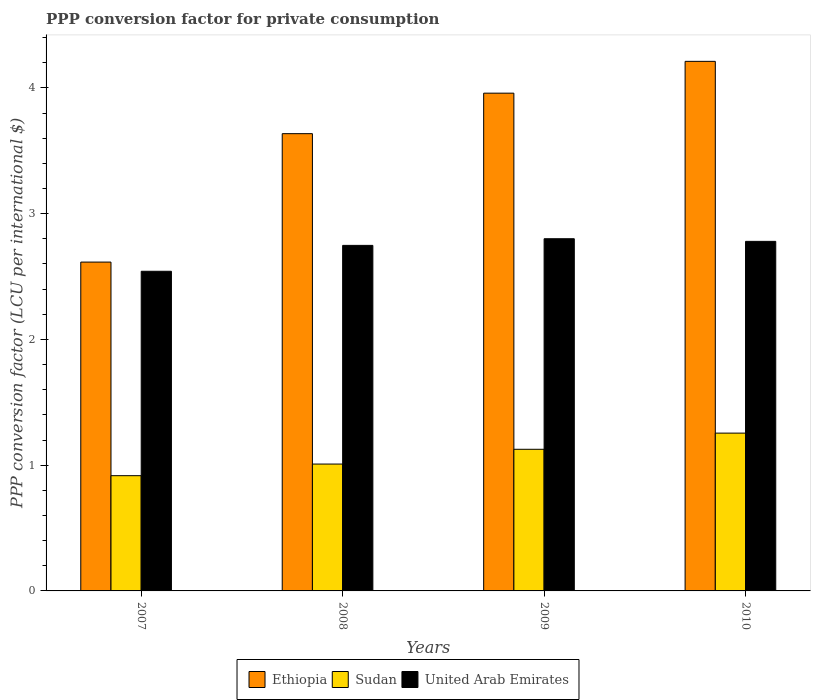How many different coloured bars are there?
Your response must be concise. 3. Are the number of bars on each tick of the X-axis equal?
Your response must be concise. Yes. What is the label of the 1st group of bars from the left?
Offer a very short reply. 2007. What is the PPP conversion factor for private consumption in Ethiopia in 2008?
Your answer should be very brief. 3.64. Across all years, what is the maximum PPP conversion factor for private consumption in United Arab Emirates?
Your response must be concise. 2.8. Across all years, what is the minimum PPP conversion factor for private consumption in United Arab Emirates?
Provide a succinct answer. 2.54. What is the total PPP conversion factor for private consumption in Sudan in the graph?
Ensure brevity in your answer.  4.31. What is the difference between the PPP conversion factor for private consumption in Sudan in 2007 and that in 2009?
Offer a terse response. -0.21. What is the difference between the PPP conversion factor for private consumption in Sudan in 2010 and the PPP conversion factor for private consumption in United Arab Emirates in 2009?
Your response must be concise. -1.55. What is the average PPP conversion factor for private consumption in United Arab Emirates per year?
Provide a short and direct response. 2.72. In the year 2007, what is the difference between the PPP conversion factor for private consumption in Ethiopia and PPP conversion factor for private consumption in United Arab Emirates?
Offer a terse response. 0.07. What is the ratio of the PPP conversion factor for private consumption in Ethiopia in 2008 to that in 2009?
Make the answer very short. 0.92. Is the PPP conversion factor for private consumption in Sudan in 2009 less than that in 2010?
Provide a short and direct response. Yes. What is the difference between the highest and the second highest PPP conversion factor for private consumption in Sudan?
Your answer should be compact. 0.13. What is the difference between the highest and the lowest PPP conversion factor for private consumption in Ethiopia?
Ensure brevity in your answer.  1.6. Is the sum of the PPP conversion factor for private consumption in Ethiopia in 2008 and 2010 greater than the maximum PPP conversion factor for private consumption in Sudan across all years?
Give a very brief answer. Yes. What does the 2nd bar from the left in 2008 represents?
Give a very brief answer. Sudan. What does the 3rd bar from the right in 2008 represents?
Ensure brevity in your answer.  Ethiopia. Is it the case that in every year, the sum of the PPP conversion factor for private consumption in United Arab Emirates and PPP conversion factor for private consumption in Sudan is greater than the PPP conversion factor for private consumption in Ethiopia?
Offer a terse response. No. How many years are there in the graph?
Ensure brevity in your answer.  4. What is the difference between two consecutive major ticks on the Y-axis?
Provide a short and direct response. 1. Does the graph contain grids?
Offer a very short reply. No. Where does the legend appear in the graph?
Provide a succinct answer. Bottom center. How are the legend labels stacked?
Your answer should be compact. Horizontal. What is the title of the graph?
Keep it short and to the point. PPP conversion factor for private consumption. What is the label or title of the X-axis?
Give a very brief answer. Years. What is the label or title of the Y-axis?
Give a very brief answer. PPP conversion factor (LCU per international $). What is the PPP conversion factor (LCU per international $) of Ethiopia in 2007?
Your response must be concise. 2.61. What is the PPP conversion factor (LCU per international $) in Sudan in 2007?
Offer a very short reply. 0.92. What is the PPP conversion factor (LCU per international $) in United Arab Emirates in 2007?
Make the answer very short. 2.54. What is the PPP conversion factor (LCU per international $) in Ethiopia in 2008?
Your response must be concise. 3.64. What is the PPP conversion factor (LCU per international $) of Sudan in 2008?
Ensure brevity in your answer.  1.01. What is the PPP conversion factor (LCU per international $) in United Arab Emirates in 2008?
Your response must be concise. 2.75. What is the PPP conversion factor (LCU per international $) in Ethiopia in 2009?
Your answer should be compact. 3.96. What is the PPP conversion factor (LCU per international $) of Sudan in 2009?
Give a very brief answer. 1.13. What is the PPP conversion factor (LCU per international $) of United Arab Emirates in 2009?
Offer a terse response. 2.8. What is the PPP conversion factor (LCU per international $) of Ethiopia in 2010?
Offer a terse response. 4.21. What is the PPP conversion factor (LCU per international $) of Sudan in 2010?
Give a very brief answer. 1.25. What is the PPP conversion factor (LCU per international $) of United Arab Emirates in 2010?
Give a very brief answer. 2.78. Across all years, what is the maximum PPP conversion factor (LCU per international $) of Ethiopia?
Provide a short and direct response. 4.21. Across all years, what is the maximum PPP conversion factor (LCU per international $) in Sudan?
Offer a very short reply. 1.25. Across all years, what is the maximum PPP conversion factor (LCU per international $) of United Arab Emirates?
Offer a terse response. 2.8. Across all years, what is the minimum PPP conversion factor (LCU per international $) of Ethiopia?
Provide a succinct answer. 2.61. Across all years, what is the minimum PPP conversion factor (LCU per international $) of Sudan?
Make the answer very short. 0.92. Across all years, what is the minimum PPP conversion factor (LCU per international $) of United Arab Emirates?
Your response must be concise. 2.54. What is the total PPP conversion factor (LCU per international $) in Ethiopia in the graph?
Offer a terse response. 14.42. What is the total PPP conversion factor (LCU per international $) of Sudan in the graph?
Provide a succinct answer. 4.31. What is the total PPP conversion factor (LCU per international $) in United Arab Emirates in the graph?
Provide a succinct answer. 10.87. What is the difference between the PPP conversion factor (LCU per international $) in Ethiopia in 2007 and that in 2008?
Provide a succinct answer. -1.02. What is the difference between the PPP conversion factor (LCU per international $) of Sudan in 2007 and that in 2008?
Ensure brevity in your answer.  -0.09. What is the difference between the PPP conversion factor (LCU per international $) of United Arab Emirates in 2007 and that in 2008?
Your answer should be very brief. -0.21. What is the difference between the PPP conversion factor (LCU per international $) of Ethiopia in 2007 and that in 2009?
Provide a succinct answer. -1.34. What is the difference between the PPP conversion factor (LCU per international $) of Sudan in 2007 and that in 2009?
Give a very brief answer. -0.21. What is the difference between the PPP conversion factor (LCU per international $) in United Arab Emirates in 2007 and that in 2009?
Keep it short and to the point. -0.26. What is the difference between the PPP conversion factor (LCU per international $) of Ethiopia in 2007 and that in 2010?
Provide a short and direct response. -1.6. What is the difference between the PPP conversion factor (LCU per international $) in Sudan in 2007 and that in 2010?
Provide a succinct answer. -0.34. What is the difference between the PPP conversion factor (LCU per international $) in United Arab Emirates in 2007 and that in 2010?
Offer a very short reply. -0.24. What is the difference between the PPP conversion factor (LCU per international $) of Ethiopia in 2008 and that in 2009?
Give a very brief answer. -0.32. What is the difference between the PPP conversion factor (LCU per international $) in Sudan in 2008 and that in 2009?
Your answer should be very brief. -0.12. What is the difference between the PPP conversion factor (LCU per international $) in United Arab Emirates in 2008 and that in 2009?
Offer a terse response. -0.05. What is the difference between the PPP conversion factor (LCU per international $) of Ethiopia in 2008 and that in 2010?
Make the answer very short. -0.57. What is the difference between the PPP conversion factor (LCU per international $) in Sudan in 2008 and that in 2010?
Your answer should be compact. -0.25. What is the difference between the PPP conversion factor (LCU per international $) in United Arab Emirates in 2008 and that in 2010?
Give a very brief answer. -0.03. What is the difference between the PPP conversion factor (LCU per international $) in Ethiopia in 2009 and that in 2010?
Offer a terse response. -0.25. What is the difference between the PPP conversion factor (LCU per international $) of Sudan in 2009 and that in 2010?
Give a very brief answer. -0.13. What is the difference between the PPP conversion factor (LCU per international $) in United Arab Emirates in 2009 and that in 2010?
Offer a very short reply. 0.02. What is the difference between the PPP conversion factor (LCU per international $) of Ethiopia in 2007 and the PPP conversion factor (LCU per international $) of Sudan in 2008?
Make the answer very short. 1.61. What is the difference between the PPP conversion factor (LCU per international $) of Ethiopia in 2007 and the PPP conversion factor (LCU per international $) of United Arab Emirates in 2008?
Offer a terse response. -0.13. What is the difference between the PPP conversion factor (LCU per international $) in Sudan in 2007 and the PPP conversion factor (LCU per international $) in United Arab Emirates in 2008?
Offer a very short reply. -1.83. What is the difference between the PPP conversion factor (LCU per international $) of Ethiopia in 2007 and the PPP conversion factor (LCU per international $) of Sudan in 2009?
Keep it short and to the point. 1.49. What is the difference between the PPP conversion factor (LCU per international $) of Ethiopia in 2007 and the PPP conversion factor (LCU per international $) of United Arab Emirates in 2009?
Keep it short and to the point. -0.19. What is the difference between the PPP conversion factor (LCU per international $) of Sudan in 2007 and the PPP conversion factor (LCU per international $) of United Arab Emirates in 2009?
Provide a short and direct response. -1.88. What is the difference between the PPP conversion factor (LCU per international $) in Ethiopia in 2007 and the PPP conversion factor (LCU per international $) in Sudan in 2010?
Offer a terse response. 1.36. What is the difference between the PPP conversion factor (LCU per international $) in Ethiopia in 2007 and the PPP conversion factor (LCU per international $) in United Arab Emirates in 2010?
Provide a short and direct response. -0.16. What is the difference between the PPP conversion factor (LCU per international $) of Sudan in 2007 and the PPP conversion factor (LCU per international $) of United Arab Emirates in 2010?
Offer a terse response. -1.86. What is the difference between the PPP conversion factor (LCU per international $) of Ethiopia in 2008 and the PPP conversion factor (LCU per international $) of Sudan in 2009?
Your response must be concise. 2.51. What is the difference between the PPP conversion factor (LCU per international $) in Ethiopia in 2008 and the PPP conversion factor (LCU per international $) in United Arab Emirates in 2009?
Give a very brief answer. 0.84. What is the difference between the PPP conversion factor (LCU per international $) of Sudan in 2008 and the PPP conversion factor (LCU per international $) of United Arab Emirates in 2009?
Your response must be concise. -1.79. What is the difference between the PPP conversion factor (LCU per international $) in Ethiopia in 2008 and the PPP conversion factor (LCU per international $) in Sudan in 2010?
Make the answer very short. 2.38. What is the difference between the PPP conversion factor (LCU per international $) in Ethiopia in 2008 and the PPP conversion factor (LCU per international $) in United Arab Emirates in 2010?
Ensure brevity in your answer.  0.86. What is the difference between the PPP conversion factor (LCU per international $) of Sudan in 2008 and the PPP conversion factor (LCU per international $) of United Arab Emirates in 2010?
Keep it short and to the point. -1.77. What is the difference between the PPP conversion factor (LCU per international $) in Ethiopia in 2009 and the PPP conversion factor (LCU per international $) in Sudan in 2010?
Provide a succinct answer. 2.7. What is the difference between the PPP conversion factor (LCU per international $) in Ethiopia in 2009 and the PPP conversion factor (LCU per international $) in United Arab Emirates in 2010?
Keep it short and to the point. 1.18. What is the difference between the PPP conversion factor (LCU per international $) of Sudan in 2009 and the PPP conversion factor (LCU per international $) of United Arab Emirates in 2010?
Offer a terse response. -1.65. What is the average PPP conversion factor (LCU per international $) of Ethiopia per year?
Your answer should be compact. 3.61. What is the average PPP conversion factor (LCU per international $) in Sudan per year?
Give a very brief answer. 1.08. What is the average PPP conversion factor (LCU per international $) of United Arab Emirates per year?
Make the answer very short. 2.72. In the year 2007, what is the difference between the PPP conversion factor (LCU per international $) of Ethiopia and PPP conversion factor (LCU per international $) of Sudan?
Provide a succinct answer. 1.7. In the year 2007, what is the difference between the PPP conversion factor (LCU per international $) of Ethiopia and PPP conversion factor (LCU per international $) of United Arab Emirates?
Offer a very short reply. 0.07. In the year 2007, what is the difference between the PPP conversion factor (LCU per international $) of Sudan and PPP conversion factor (LCU per international $) of United Arab Emirates?
Give a very brief answer. -1.63. In the year 2008, what is the difference between the PPP conversion factor (LCU per international $) of Ethiopia and PPP conversion factor (LCU per international $) of Sudan?
Keep it short and to the point. 2.63. In the year 2008, what is the difference between the PPP conversion factor (LCU per international $) of Ethiopia and PPP conversion factor (LCU per international $) of United Arab Emirates?
Your answer should be very brief. 0.89. In the year 2008, what is the difference between the PPP conversion factor (LCU per international $) in Sudan and PPP conversion factor (LCU per international $) in United Arab Emirates?
Your answer should be very brief. -1.74. In the year 2009, what is the difference between the PPP conversion factor (LCU per international $) of Ethiopia and PPP conversion factor (LCU per international $) of Sudan?
Provide a succinct answer. 2.83. In the year 2009, what is the difference between the PPP conversion factor (LCU per international $) in Ethiopia and PPP conversion factor (LCU per international $) in United Arab Emirates?
Your answer should be compact. 1.16. In the year 2009, what is the difference between the PPP conversion factor (LCU per international $) in Sudan and PPP conversion factor (LCU per international $) in United Arab Emirates?
Ensure brevity in your answer.  -1.67. In the year 2010, what is the difference between the PPP conversion factor (LCU per international $) of Ethiopia and PPP conversion factor (LCU per international $) of Sudan?
Provide a succinct answer. 2.96. In the year 2010, what is the difference between the PPP conversion factor (LCU per international $) of Ethiopia and PPP conversion factor (LCU per international $) of United Arab Emirates?
Make the answer very short. 1.43. In the year 2010, what is the difference between the PPP conversion factor (LCU per international $) of Sudan and PPP conversion factor (LCU per international $) of United Arab Emirates?
Keep it short and to the point. -1.52. What is the ratio of the PPP conversion factor (LCU per international $) in Ethiopia in 2007 to that in 2008?
Provide a short and direct response. 0.72. What is the ratio of the PPP conversion factor (LCU per international $) in Sudan in 2007 to that in 2008?
Your response must be concise. 0.91. What is the ratio of the PPP conversion factor (LCU per international $) of United Arab Emirates in 2007 to that in 2008?
Make the answer very short. 0.93. What is the ratio of the PPP conversion factor (LCU per international $) in Ethiopia in 2007 to that in 2009?
Offer a very short reply. 0.66. What is the ratio of the PPP conversion factor (LCU per international $) in Sudan in 2007 to that in 2009?
Provide a short and direct response. 0.81. What is the ratio of the PPP conversion factor (LCU per international $) in United Arab Emirates in 2007 to that in 2009?
Offer a terse response. 0.91. What is the ratio of the PPP conversion factor (LCU per international $) of Ethiopia in 2007 to that in 2010?
Give a very brief answer. 0.62. What is the ratio of the PPP conversion factor (LCU per international $) of Sudan in 2007 to that in 2010?
Your answer should be compact. 0.73. What is the ratio of the PPP conversion factor (LCU per international $) of United Arab Emirates in 2007 to that in 2010?
Offer a very short reply. 0.91. What is the ratio of the PPP conversion factor (LCU per international $) of Ethiopia in 2008 to that in 2009?
Your answer should be compact. 0.92. What is the ratio of the PPP conversion factor (LCU per international $) of Sudan in 2008 to that in 2009?
Give a very brief answer. 0.9. What is the ratio of the PPP conversion factor (LCU per international $) of United Arab Emirates in 2008 to that in 2009?
Your answer should be very brief. 0.98. What is the ratio of the PPP conversion factor (LCU per international $) of Ethiopia in 2008 to that in 2010?
Your response must be concise. 0.86. What is the ratio of the PPP conversion factor (LCU per international $) in Sudan in 2008 to that in 2010?
Provide a succinct answer. 0.8. What is the ratio of the PPP conversion factor (LCU per international $) in United Arab Emirates in 2008 to that in 2010?
Make the answer very short. 0.99. What is the ratio of the PPP conversion factor (LCU per international $) in Ethiopia in 2009 to that in 2010?
Keep it short and to the point. 0.94. What is the ratio of the PPP conversion factor (LCU per international $) of Sudan in 2009 to that in 2010?
Give a very brief answer. 0.9. What is the ratio of the PPP conversion factor (LCU per international $) in United Arab Emirates in 2009 to that in 2010?
Give a very brief answer. 1.01. What is the difference between the highest and the second highest PPP conversion factor (LCU per international $) of Ethiopia?
Your answer should be very brief. 0.25. What is the difference between the highest and the second highest PPP conversion factor (LCU per international $) in Sudan?
Your answer should be very brief. 0.13. What is the difference between the highest and the second highest PPP conversion factor (LCU per international $) of United Arab Emirates?
Offer a terse response. 0.02. What is the difference between the highest and the lowest PPP conversion factor (LCU per international $) of Ethiopia?
Your response must be concise. 1.6. What is the difference between the highest and the lowest PPP conversion factor (LCU per international $) in Sudan?
Give a very brief answer. 0.34. What is the difference between the highest and the lowest PPP conversion factor (LCU per international $) in United Arab Emirates?
Your answer should be compact. 0.26. 